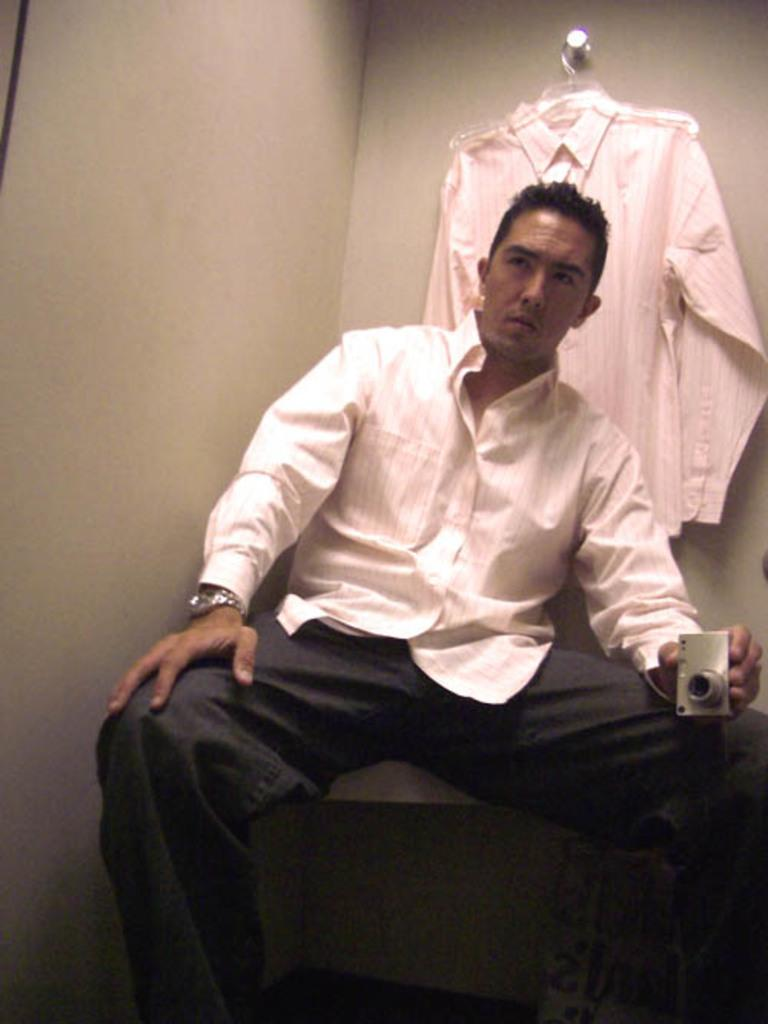What is the man in the image doing? The man is sitting in the image. What is the man holding in the image? The man is holding a camera. What can be seen hanging behind the man? There is a shirt hanged on a rod behind the man. What is visible in the background of the image? There is a wall in the background of the image. What type of turkey is being prepared in the image? There is no turkey present in the image; it features a man sitting with a camera and a shirt hanging behind him. 